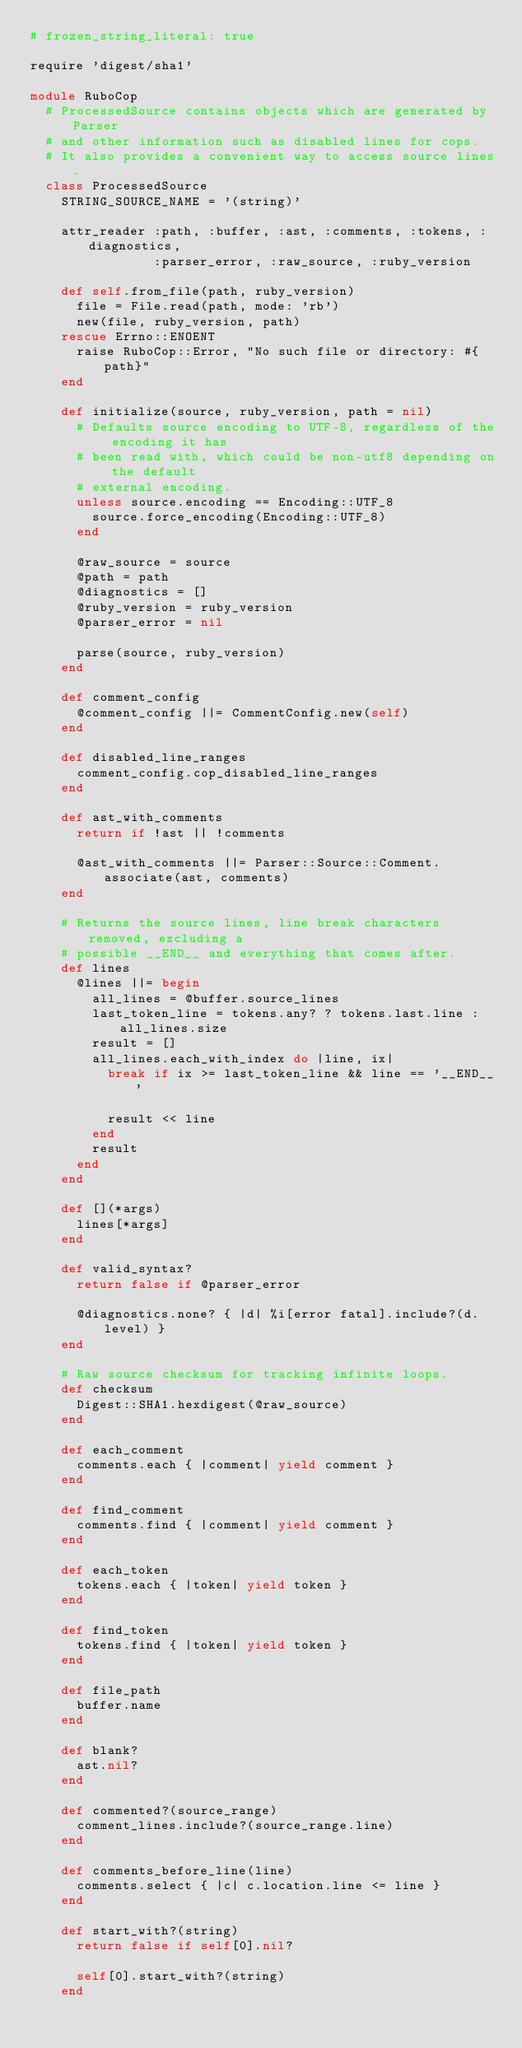Convert code to text. <code><loc_0><loc_0><loc_500><loc_500><_Ruby_># frozen_string_literal: true

require 'digest/sha1'

module RuboCop
  # ProcessedSource contains objects which are generated by Parser
  # and other information such as disabled lines for cops.
  # It also provides a convenient way to access source lines.
  class ProcessedSource
    STRING_SOURCE_NAME = '(string)'

    attr_reader :path, :buffer, :ast, :comments, :tokens, :diagnostics,
                :parser_error, :raw_source, :ruby_version

    def self.from_file(path, ruby_version)
      file = File.read(path, mode: 'rb')
      new(file, ruby_version, path)
    rescue Errno::ENOENT
      raise RuboCop::Error, "No such file or directory: #{path}"
    end

    def initialize(source, ruby_version, path = nil)
      # Defaults source encoding to UTF-8, regardless of the encoding it has
      # been read with, which could be non-utf8 depending on the default
      # external encoding.
      unless source.encoding == Encoding::UTF_8
        source.force_encoding(Encoding::UTF_8)
      end

      @raw_source = source
      @path = path
      @diagnostics = []
      @ruby_version = ruby_version
      @parser_error = nil

      parse(source, ruby_version)
    end

    def comment_config
      @comment_config ||= CommentConfig.new(self)
    end

    def disabled_line_ranges
      comment_config.cop_disabled_line_ranges
    end

    def ast_with_comments
      return if !ast || !comments

      @ast_with_comments ||= Parser::Source::Comment.associate(ast, comments)
    end

    # Returns the source lines, line break characters removed, excluding a
    # possible __END__ and everything that comes after.
    def lines
      @lines ||= begin
        all_lines = @buffer.source_lines
        last_token_line = tokens.any? ? tokens.last.line : all_lines.size
        result = []
        all_lines.each_with_index do |line, ix|
          break if ix >= last_token_line && line == '__END__'

          result << line
        end
        result
      end
    end

    def [](*args)
      lines[*args]
    end

    def valid_syntax?
      return false if @parser_error

      @diagnostics.none? { |d| %i[error fatal].include?(d.level) }
    end

    # Raw source checksum for tracking infinite loops.
    def checksum
      Digest::SHA1.hexdigest(@raw_source)
    end

    def each_comment
      comments.each { |comment| yield comment }
    end

    def find_comment
      comments.find { |comment| yield comment }
    end

    def each_token
      tokens.each { |token| yield token }
    end

    def find_token
      tokens.find { |token| yield token }
    end

    def file_path
      buffer.name
    end

    def blank?
      ast.nil?
    end

    def commented?(source_range)
      comment_lines.include?(source_range.line)
    end

    def comments_before_line(line)
      comments.select { |c| c.location.line <= line }
    end

    def start_with?(string)
      return false if self[0].nil?

      self[0].start_with?(string)
    end
</code> 